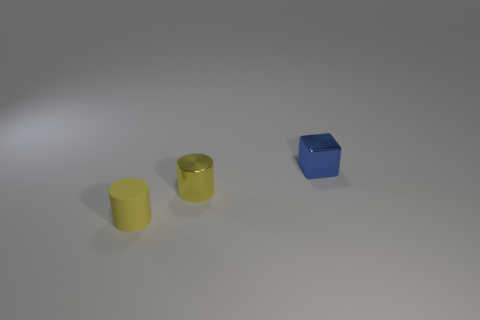How do the textures of the different objects compare? In this image, the two yellow cylinders appear to differ in texture: one cylinder has a matte finish that diffuses light, giving it a soft look, while the other has a slightly reflective metallic finish, which seems to pick up more of the surrounding light and shadow. The blue cube has a glossy texture which reflects light sharply, giving it a smooth and sleek appearance. 